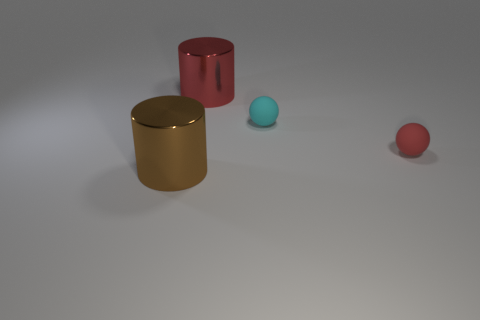Are there any cyan balls in front of the tiny red sphere?
Your answer should be compact. No. There is a large thing that is behind the brown metallic object; are there any small cyan things that are behind it?
Keep it short and to the point. No. Is the number of spheres to the left of the small cyan rubber sphere the same as the number of tiny red things on the right side of the red rubber ball?
Your response must be concise. Yes. There is a thing that is the same material as the tiny cyan ball; what color is it?
Ensure brevity in your answer.  Red. Are there any large brown objects made of the same material as the small red thing?
Offer a very short reply. No. How many things are either tiny red rubber cylinders or brown shiny cylinders?
Your response must be concise. 1. Are the tiny red object and the small thing behind the small red object made of the same material?
Keep it short and to the point. Yes. How big is the shiny cylinder to the right of the large brown cylinder?
Your answer should be very brief. Large. Is the number of blue things less than the number of cylinders?
Provide a succinct answer. Yes. There is a thing that is to the right of the brown cylinder and in front of the tiny cyan thing; what shape is it?
Make the answer very short. Sphere. 